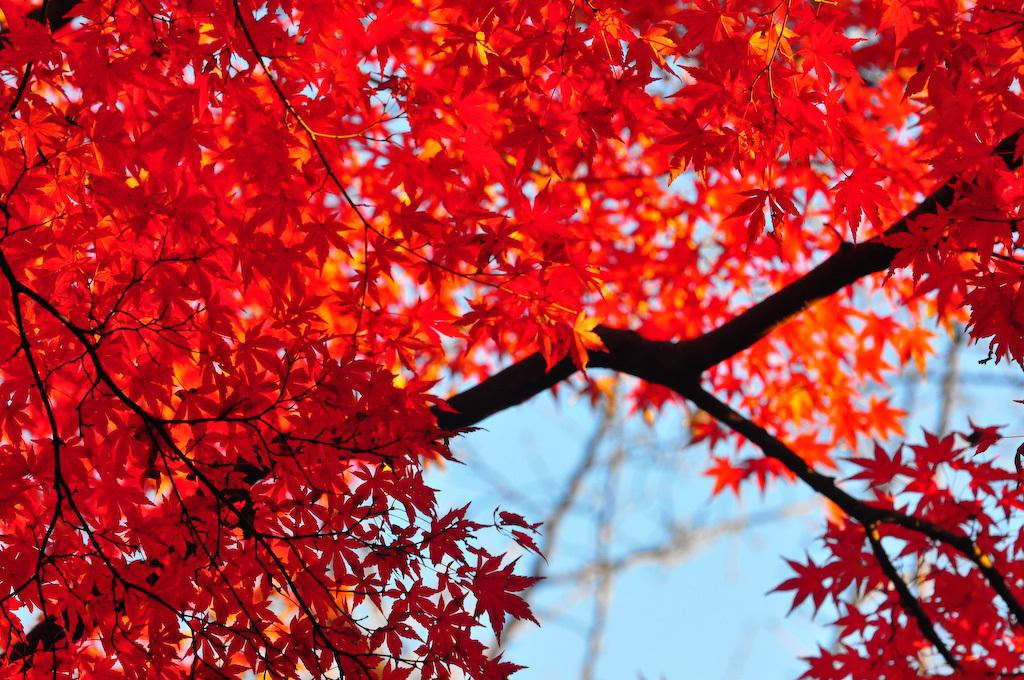What is the main subject of the picture? The main subject of the picture is a tree. What features can be observed on the tree? The tree has branches and leaves. What is the condition of the sky in the picture? The sky is clear in the picture. What type of territory can be seen in the image? There is no territory present in the image; it features a tree with branches and leaves. Can you tell me how many flames are visible in the image? There are no flames present in the image. 